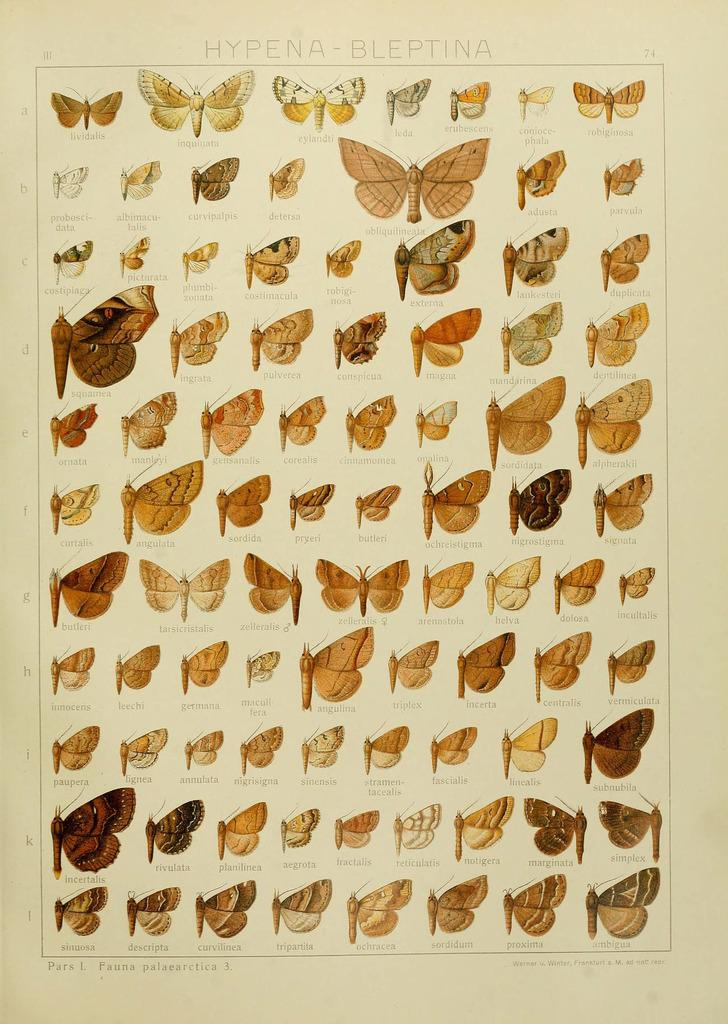What is depicted on the paper in the image? The paper contains images of butterflies. What else can be found on the paper besides the butterfly images? There is text on the paper. How many chairs are visible in the image? There are no chairs present in the image; it only features a paper with butterfly images and text. Is there a cobweb visible in the image? There is no cobweb present in the image. 